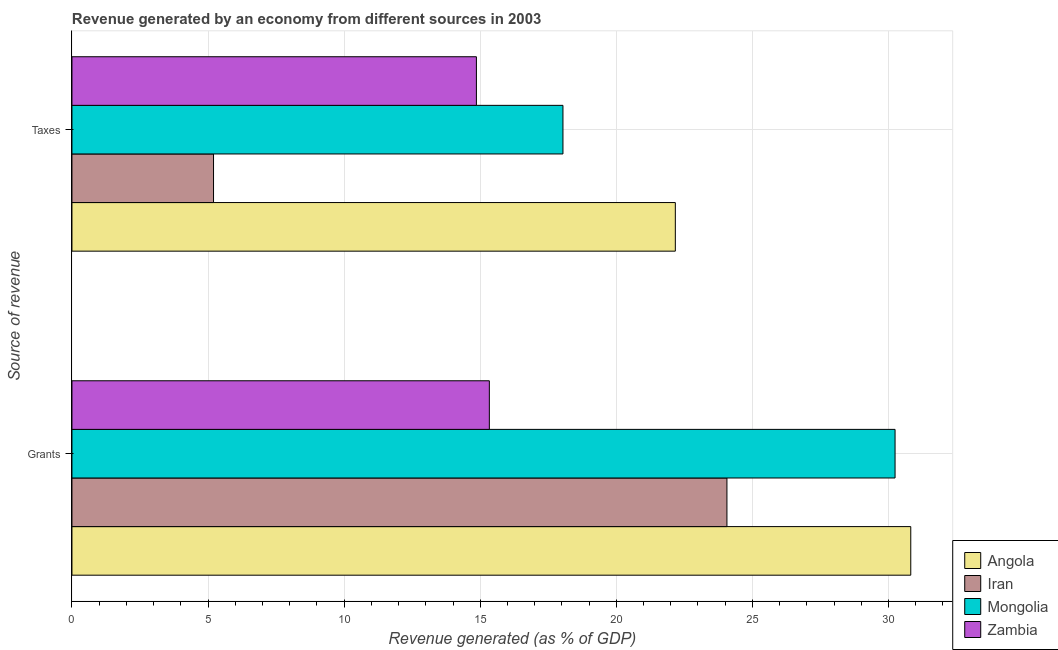How many different coloured bars are there?
Your answer should be very brief. 4. How many groups of bars are there?
Provide a succinct answer. 2. Are the number of bars per tick equal to the number of legend labels?
Your response must be concise. Yes. Are the number of bars on each tick of the Y-axis equal?
Your answer should be compact. Yes. What is the label of the 1st group of bars from the top?
Your response must be concise. Taxes. What is the revenue generated by grants in Iran?
Give a very brief answer. 24.06. Across all countries, what is the maximum revenue generated by grants?
Give a very brief answer. 30.82. Across all countries, what is the minimum revenue generated by taxes?
Your response must be concise. 5.2. In which country was the revenue generated by grants maximum?
Provide a short and direct response. Angola. In which country was the revenue generated by grants minimum?
Provide a short and direct response. Zambia. What is the total revenue generated by grants in the graph?
Provide a short and direct response. 100.46. What is the difference between the revenue generated by grants in Mongolia and that in Angola?
Keep it short and to the point. -0.58. What is the difference between the revenue generated by taxes in Angola and the revenue generated by grants in Iran?
Offer a very short reply. -1.9. What is the average revenue generated by taxes per country?
Provide a succinct answer. 15.07. What is the difference between the revenue generated by taxes and revenue generated by grants in Iran?
Ensure brevity in your answer.  -18.86. In how many countries, is the revenue generated by grants greater than 29 %?
Offer a very short reply. 2. What is the ratio of the revenue generated by grants in Zambia to that in Iran?
Offer a very short reply. 0.64. What does the 1st bar from the top in Taxes represents?
Provide a succinct answer. Zambia. What does the 2nd bar from the bottom in Taxes represents?
Make the answer very short. Iran. How many bars are there?
Keep it short and to the point. 8. Are all the bars in the graph horizontal?
Provide a short and direct response. Yes. How many countries are there in the graph?
Offer a very short reply. 4. Does the graph contain any zero values?
Ensure brevity in your answer.  No. What is the title of the graph?
Make the answer very short. Revenue generated by an economy from different sources in 2003. What is the label or title of the X-axis?
Your answer should be compact. Revenue generated (as % of GDP). What is the label or title of the Y-axis?
Make the answer very short. Source of revenue. What is the Revenue generated (as % of GDP) of Angola in Grants?
Keep it short and to the point. 30.82. What is the Revenue generated (as % of GDP) of Iran in Grants?
Keep it short and to the point. 24.06. What is the Revenue generated (as % of GDP) of Mongolia in Grants?
Give a very brief answer. 30.24. What is the Revenue generated (as % of GDP) of Zambia in Grants?
Your answer should be compact. 15.33. What is the Revenue generated (as % of GDP) of Angola in Taxes?
Your response must be concise. 22.17. What is the Revenue generated (as % of GDP) of Iran in Taxes?
Your response must be concise. 5.2. What is the Revenue generated (as % of GDP) of Mongolia in Taxes?
Your response must be concise. 18.04. What is the Revenue generated (as % of GDP) of Zambia in Taxes?
Make the answer very short. 14.86. Across all Source of revenue, what is the maximum Revenue generated (as % of GDP) in Angola?
Ensure brevity in your answer.  30.82. Across all Source of revenue, what is the maximum Revenue generated (as % of GDP) in Iran?
Provide a short and direct response. 24.06. Across all Source of revenue, what is the maximum Revenue generated (as % of GDP) in Mongolia?
Ensure brevity in your answer.  30.24. Across all Source of revenue, what is the maximum Revenue generated (as % of GDP) of Zambia?
Provide a succinct answer. 15.33. Across all Source of revenue, what is the minimum Revenue generated (as % of GDP) in Angola?
Your answer should be very brief. 22.17. Across all Source of revenue, what is the minimum Revenue generated (as % of GDP) of Iran?
Your response must be concise. 5.2. Across all Source of revenue, what is the minimum Revenue generated (as % of GDP) of Mongolia?
Your answer should be compact. 18.04. Across all Source of revenue, what is the minimum Revenue generated (as % of GDP) in Zambia?
Offer a very short reply. 14.86. What is the total Revenue generated (as % of GDP) in Angola in the graph?
Offer a very short reply. 52.98. What is the total Revenue generated (as % of GDP) in Iran in the graph?
Give a very brief answer. 29.26. What is the total Revenue generated (as % of GDP) in Mongolia in the graph?
Your answer should be very brief. 48.28. What is the total Revenue generated (as % of GDP) of Zambia in the graph?
Your response must be concise. 30.19. What is the difference between the Revenue generated (as % of GDP) of Angola in Grants and that in Taxes?
Make the answer very short. 8.65. What is the difference between the Revenue generated (as % of GDP) in Iran in Grants and that in Taxes?
Your answer should be compact. 18.86. What is the difference between the Revenue generated (as % of GDP) in Mongolia in Grants and that in Taxes?
Offer a terse response. 12.2. What is the difference between the Revenue generated (as % of GDP) of Zambia in Grants and that in Taxes?
Make the answer very short. 0.48. What is the difference between the Revenue generated (as % of GDP) of Angola in Grants and the Revenue generated (as % of GDP) of Iran in Taxes?
Provide a short and direct response. 25.62. What is the difference between the Revenue generated (as % of GDP) in Angola in Grants and the Revenue generated (as % of GDP) in Mongolia in Taxes?
Give a very brief answer. 12.78. What is the difference between the Revenue generated (as % of GDP) of Angola in Grants and the Revenue generated (as % of GDP) of Zambia in Taxes?
Make the answer very short. 15.96. What is the difference between the Revenue generated (as % of GDP) of Iran in Grants and the Revenue generated (as % of GDP) of Mongolia in Taxes?
Make the answer very short. 6.02. What is the difference between the Revenue generated (as % of GDP) in Iran in Grants and the Revenue generated (as % of GDP) in Zambia in Taxes?
Give a very brief answer. 9.2. What is the difference between the Revenue generated (as % of GDP) of Mongolia in Grants and the Revenue generated (as % of GDP) of Zambia in Taxes?
Provide a succinct answer. 15.38. What is the average Revenue generated (as % of GDP) in Angola per Source of revenue?
Give a very brief answer. 26.49. What is the average Revenue generated (as % of GDP) of Iran per Source of revenue?
Keep it short and to the point. 14.63. What is the average Revenue generated (as % of GDP) of Mongolia per Source of revenue?
Ensure brevity in your answer.  24.14. What is the average Revenue generated (as % of GDP) of Zambia per Source of revenue?
Give a very brief answer. 15.1. What is the difference between the Revenue generated (as % of GDP) of Angola and Revenue generated (as % of GDP) of Iran in Grants?
Your response must be concise. 6.75. What is the difference between the Revenue generated (as % of GDP) in Angola and Revenue generated (as % of GDP) in Mongolia in Grants?
Ensure brevity in your answer.  0.58. What is the difference between the Revenue generated (as % of GDP) of Angola and Revenue generated (as % of GDP) of Zambia in Grants?
Keep it short and to the point. 15.48. What is the difference between the Revenue generated (as % of GDP) in Iran and Revenue generated (as % of GDP) in Mongolia in Grants?
Make the answer very short. -6.18. What is the difference between the Revenue generated (as % of GDP) of Iran and Revenue generated (as % of GDP) of Zambia in Grants?
Provide a succinct answer. 8.73. What is the difference between the Revenue generated (as % of GDP) in Mongolia and Revenue generated (as % of GDP) in Zambia in Grants?
Keep it short and to the point. 14.91. What is the difference between the Revenue generated (as % of GDP) in Angola and Revenue generated (as % of GDP) in Iran in Taxes?
Provide a succinct answer. 16.97. What is the difference between the Revenue generated (as % of GDP) of Angola and Revenue generated (as % of GDP) of Mongolia in Taxes?
Provide a succinct answer. 4.13. What is the difference between the Revenue generated (as % of GDP) in Angola and Revenue generated (as % of GDP) in Zambia in Taxes?
Your answer should be very brief. 7.31. What is the difference between the Revenue generated (as % of GDP) in Iran and Revenue generated (as % of GDP) in Mongolia in Taxes?
Provide a succinct answer. -12.84. What is the difference between the Revenue generated (as % of GDP) in Iran and Revenue generated (as % of GDP) in Zambia in Taxes?
Your response must be concise. -9.66. What is the difference between the Revenue generated (as % of GDP) of Mongolia and Revenue generated (as % of GDP) of Zambia in Taxes?
Your answer should be very brief. 3.18. What is the ratio of the Revenue generated (as % of GDP) of Angola in Grants to that in Taxes?
Give a very brief answer. 1.39. What is the ratio of the Revenue generated (as % of GDP) of Iran in Grants to that in Taxes?
Provide a succinct answer. 4.63. What is the ratio of the Revenue generated (as % of GDP) of Mongolia in Grants to that in Taxes?
Your response must be concise. 1.68. What is the ratio of the Revenue generated (as % of GDP) in Zambia in Grants to that in Taxes?
Make the answer very short. 1.03. What is the difference between the highest and the second highest Revenue generated (as % of GDP) of Angola?
Offer a very short reply. 8.65. What is the difference between the highest and the second highest Revenue generated (as % of GDP) of Iran?
Provide a short and direct response. 18.86. What is the difference between the highest and the second highest Revenue generated (as % of GDP) of Mongolia?
Keep it short and to the point. 12.2. What is the difference between the highest and the second highest Revenue generated (as % of GDP) in Zambia?
Make the answer very short. 0.48. What is the difference between the highest and the lowest Revenue generated (as % of GDP) of Angola?
Your answer should be compact. 8.65. What is the difference between the highest and the lowest Revenue generated (as % of GDP) of Iran?
Provide a succinct answer. 18.86. What is the difference between the highest and the lowest Revenue generated (as % of GDP) in Mongolia?
Ensure brevity in your answer.  12.2. What is the difference between the highest and the lowest Revenue generated (as % of GDP) of Zambia?
Offer a terse response. 0.48. 